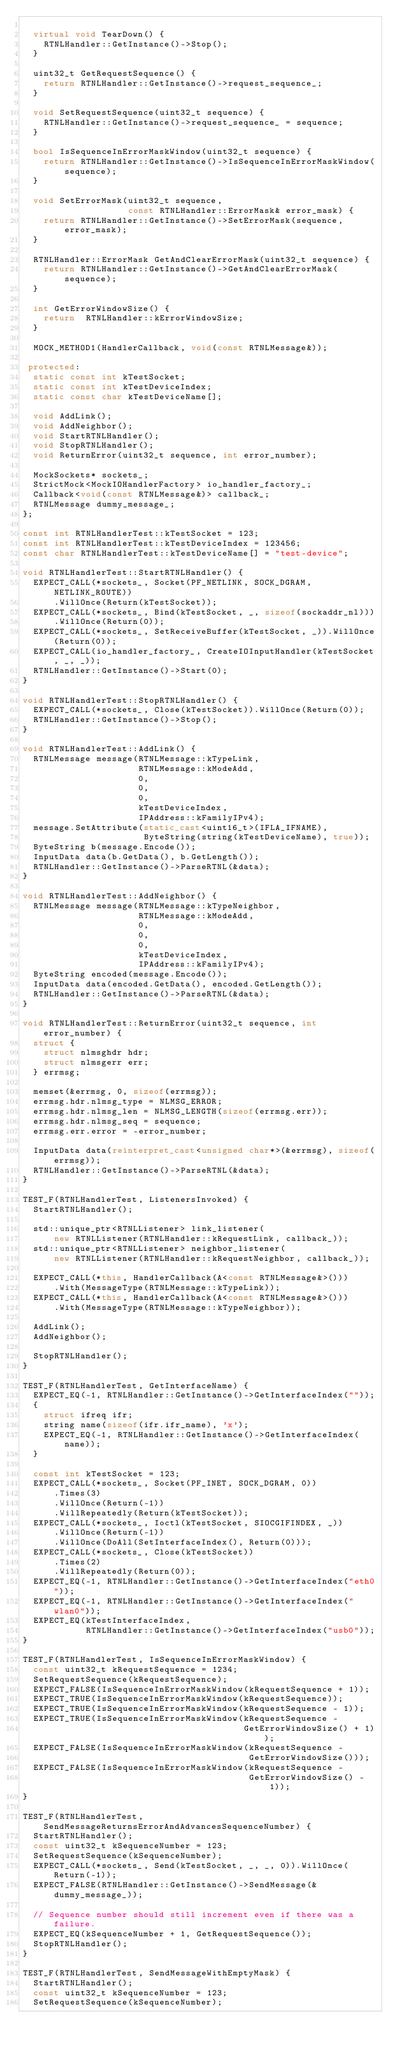Convert code to text. <code><loc_0><loc_0><loc_500><loc_500><_C++_>
  virtual void TearDown() {
    RTNLHandler::GetInstance()->Stop();
  }

  uint32_t GetRequestSequence() {
    return RTNLHandler::GetInstance()->request_sequence_;
  }

  void SetRequestSequence(uint32_t sequence) {
    RTNLHandler::GetInstance()->request_sequence_ = sequence;
  }

  bool IsSequenceInErrorMaskWindow(uint32_t sequence) {
    return RTNLHandler::GetInstance()->IsSequenceInErrorMaskWindow(sequence);
  }

  void SetErrorMask(uint32_t sequence,
                    const RTNLHandler::ErrorMask& error_mask) {
    return RTNLHandler::GetInstance()->SetErrorMask(sequence, error_mask);
  }

  RTNLHandler::ErrorMask GetAndClearErrorMask(uint32_t sequence) {
    return RTNLHandler::GetInstance()->GetAndClearErrorMask(sequence);
  }

  int GetErrorWindowSize() {
    return  RTNLHandler::kErrorWindowSize;
  }

  MOCK_METHOD1(HandlerCallback, void(const RTNLMessage&));

 protected:
  static const int kTestSocket;
  static const int kTestDeviceIndex;
  static const char kTestDeviceName[];

  void AddLink();
  void AddNeighbor();
  void StartRTNLHandler();
  void StopRTNLHandler();
  void ReturnError(uint32_t sequence, int error_number);

  MockSockets* sockets_;
  StrictMock<MockIOHandlerFactory> io_handler_factory_;
  Callback<void(const RTNLMessage&)> callback_;
  RTNLMessage dummy_message_;
};

const int RTNLHandlerTest::kTestSocket = 123;
const int RTNLHandlerTest::kTestDeviceIndex = 123456;
const char RTNLHandlerTest::kTestDeviceName[] = "test-device";

void RTNLHandlerTest::StartRTNLHandler() {
  EXPECT_CALL(*sockets_, Socket(PF_NETLINK, SOCK_DGRAM, NETLINK_ROUTE))
      .WillOnce(Return(kTestSocket));
  EXPECT_CALL(*sockets_, Bind(kTestSocket, _, sizeof(sockaddr_nl)))
      .WillOnce(Return(0));
  EXPECT_CALL(*sockets_, SetReceiveBuffer(kTestSocket, _)).WillOnce(Return(0));
  EXPECT_CALL(io_handler_factory_, CreateIOInputHandler(kTestSocket, _, _));
  RTNLHandler::GetInstance()->Start(0);
}

void RTNLHandlerTest::StopRTNLHandler() {
  EXPECT_CALL(*sockets_, Close(kTestSocket)).WillOnce(Return(0));
  RTNLHandler::GetInstance()->Stop();
}

void RTNLHandlerTest::AddLink() {
  RTNLMessage message(RTNLMessage::kTypeLink,
                      RTNLMessage::kModeAdd,
                      0,
                      0,
                      0,
                      kTestDeviceIndex,
                      IPAddress::kFamilyIPv4);
  message.SetAttribute(static_cast<uint16_t>(IFLA_IFNAME),
                       ByteString(string(kTestDeviceName), true));
  ByteString b(message.Encode());
  InputData data(b.GetData(), b.GetLength());
  RTNLHandler::GetInstance()->ParseRTNL(&data);
}

void RTNLHandlerTest::AddNeighbor() {
  RTNLMessage message(RTNLMessage::kTypeNeighbor,
                      RTNLMessage::kModeAdd,
                      0,
                      0,
                      0,
                      kTestDeviceIndex,
                      IPAddress::kFamilyIPv4);
  ByteString encoded(message.Encode());
  InputData data(encoded.GetData(), encoded.GetLength());
  RTNLHandler::GetInstance()->ParseRTNL(&data);
}

void RTNLHandlerTest::ReturnError(uint32_t sequence, int error_number) {
  struct {
    struct nlmsghdr hdr;
    struct nlmsgerr err;
  } errmsg;

  memset(&errmsg, 0, sizeof(errmsg));
  errmsg.hdr.nlmsg_type = NLMSG_ERROR;
  errmsg.hdr.nlmsg_len = NLMSG_LENGTH(sizeof(errmsg.err));
  errmsg.hdr.nlmsg_seq = sequence;
  errmsg.err.error = -error_number;

  InputData data(reinterpret_cast<unsigned char*>(&errmsg), sizeof(errmsg));
  RTNLHandler::GetInstance()->ParseRTNL(&data);
}

TEST_F(RTNLHandlerTest, ListenersInvoked) {
  StartRTNLHandler();

  std::unique_ptr<RTNLListener> link_listener(
      new RTNLListener(RTNLHandler::kRequestLink, callback_));
  std::unique_ptr<RTNLListener> neighbor_listener(
      new RTNLListener(RTNLHandler::kRequestNeighbor, callback_));

  EXPECT_CALL(*this, HandlerCallback(A<const RTNLMessage&>()))
      .With(MessageType(RTNLMessage::kTypeLink));
  EXPECT_CALL(*this, HandlerCallback(A<const RTNLMessage&>()))
      .With(MessageType(RTNLMessage::kTypeNeighbor));

  AddLink();
  AddNeighbor();

  StopRTNLHandler();
}

TEST_F(RTNLHandlerTest, GetInterfaceName) {
  EXPECT_EQ(-1, RTNLHandler::GetInstance()->GetInterfaceIndex(""));
  {
    struct ifreq ifr;
    string name(sizeof(ifr.ifr_name), 'x');
    EXPECT_EQ(-1, RTNLHandler::GetInstance()->GetInterfaceIndex(name));
  }

  const int kTestSocket = 123;
  EXPECT_CALL(*sockets_, Socket(PF_INET, SOCK_DGRAM, 0))
      .Times(3)
      .WillOnce(Return(-1))
      .WillRepeatedly(Return(kTestSocket));
  EXPECT_CALL(*sockets_, Ioctl(kTestSocket, SIOCGIFINDEX, _))
      .WillOnce(Return(-1))
      .WillOnce(DoAll(SetInterfaceIndex(), Return(0)));
  EXPECT_CALL(*sockets_, Close(kTestSocket))
      .Times(2)
      .WillRepeatedly(Return(0));
  EXPECT_EQ(-1, RTNLHandler::GetInstance()->GetInterfaceIndex("eth0"));
  EXPECT_EQ(-1, RTNLHandler::GetInstance()->GetInterfaceIndex("wlan0"));
  EXPECT_EQ(kTestInterfaceIndex,
            RTNLHandler::GetInstance()->GetInterfaceIndex("usb0"));
}

TEST_F(RTNLHandlerTest, IsSequenceInErrorMaskWindow) {
  const uint32_t kRequestSequence = 1234;
  SetRequestSequence(kRequestSequence);
  EXPECT_FALSE(IsSequenceInErrorMaskWindow(kRequestSequence + 1));
  EXPECT_TRUE(IsSequenceInErrorMaskWindow(kRequestSequence));
  EXPECT_TRUE(IsSequenceInErrorMaskWindow(kRequestSequence - 1));
  EXPECT_TRUE(IsSequenceInErrorMaskWindow(kRequestSequence -
                                          GetErrorWindowSize() + 1));
  EXPECT_FALSE(IsSequenceInErrorMaskWindow(kRequestSequence -
                                           GetErrorWindowSize()));
  EXPECT_FALSE(IsSequenceInErrorMaskWindow(kRequestSequence -
                                           GetErrorWindowSize() - 1));
}

TEST_F(RTNLHandlerTest, SendMessageReturnsErrorAndAdvancesSequenceNumber) {
  StartRTNLHandler();
  const uint32_t kSequenceNumber = 123;
  SetRequestSequence(kSequenceNumber);
  EXPECT_CALL(*sockets_, Send(kTestSocket, _, _, 0)).WillOnce(Return(-1));
  EXPECT_FALSE(RTNLHandler::GetInstance()->SendMessage(&dummy_message_));

  // Sequence number should still increment even if there was a failure.
  EXPECT_EQ(kSequenceNumber + 1, GetRequestSequence());
  StopRTNLHandler();
}

TEST_F(RTNLHandlerTest, SendMessageWithEmptyMask) {
  StartRTNLHandler();
  const uint32_t kSequenceNumber = 123;
  SetRequestSequence(kSequenceNumber);</code> 